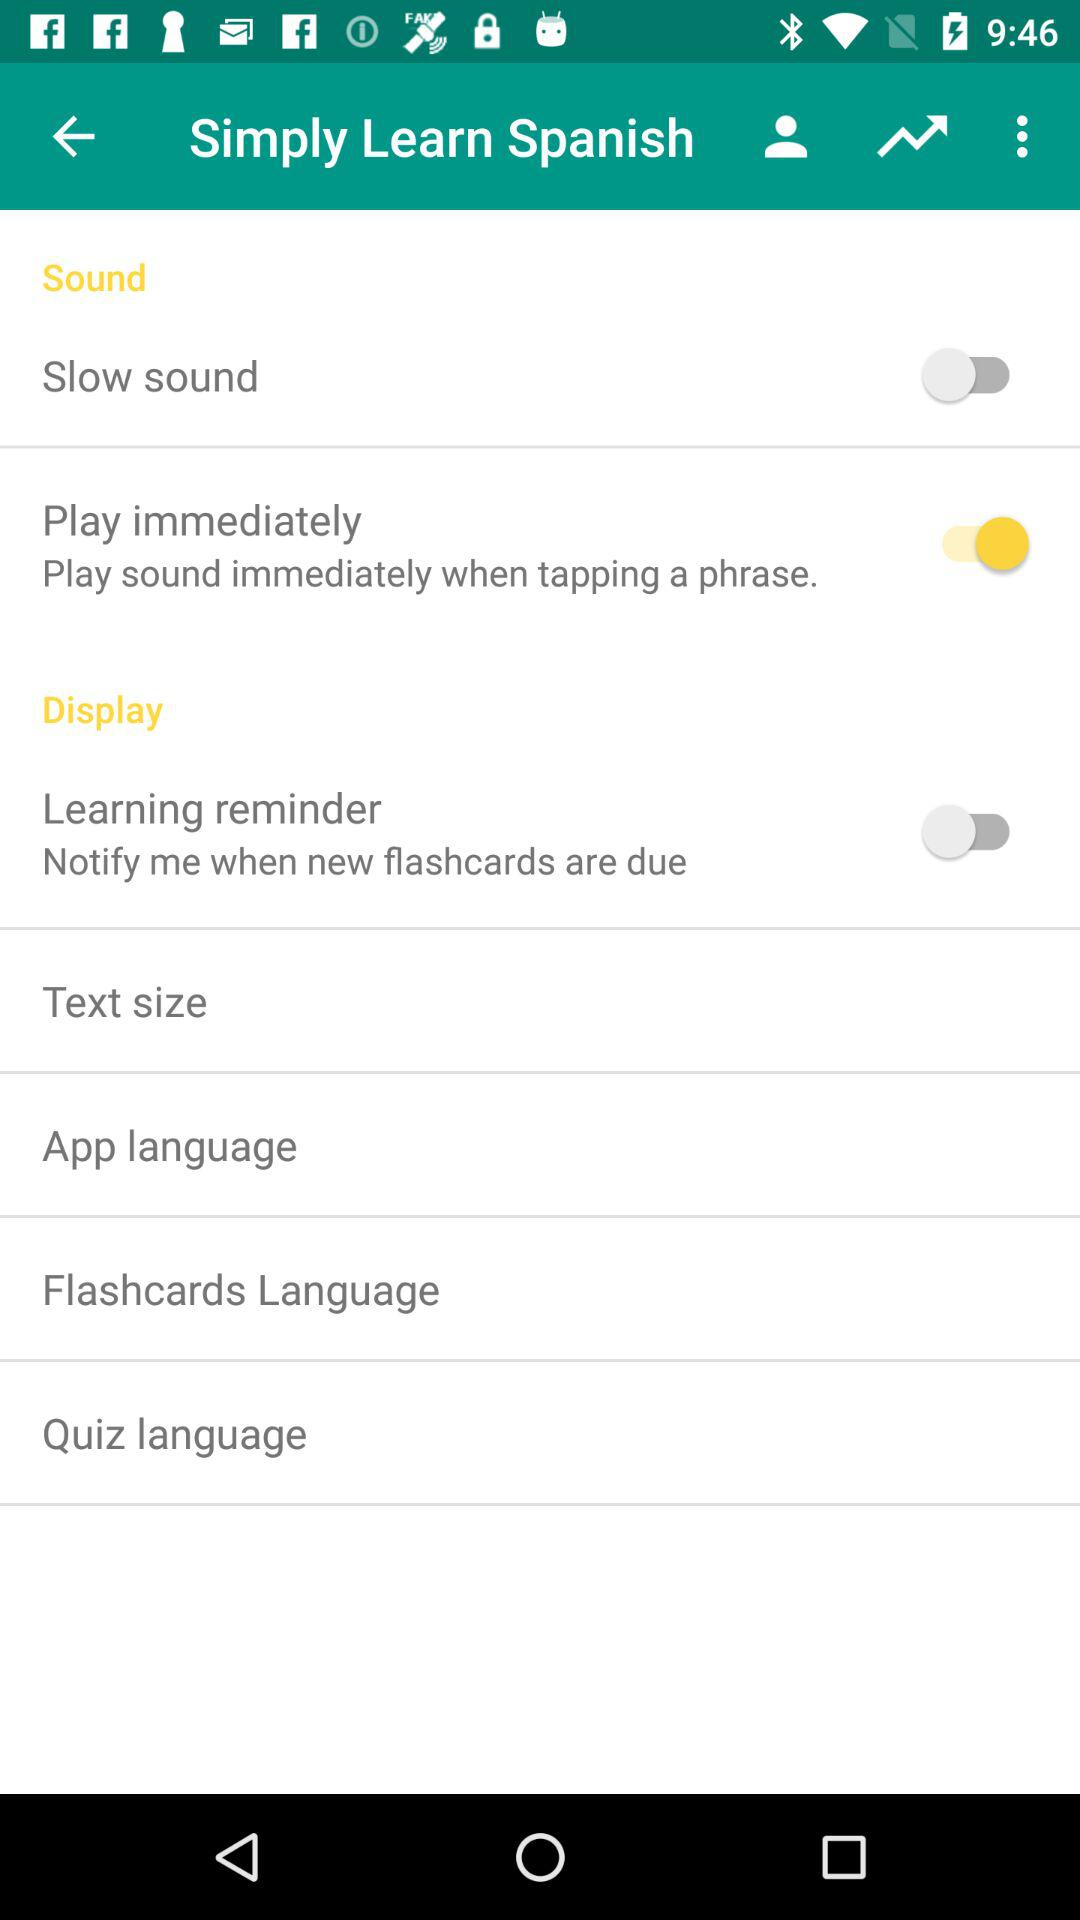What is the status of "Play immediately"? The status is "on". 